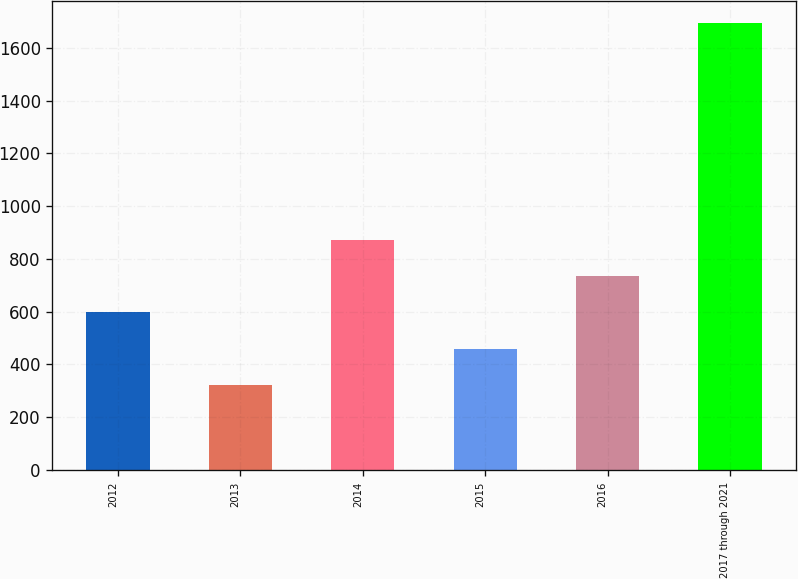Convert chart. <chart><loc_0><loc_0><loc_500><loc_500><bar_chart><fcel>2012<fcel>2013<fcel>2014<fcel>2015<fcel>2016<fcel>2017 through 2021<nl><fcel>597.2<fcel>323<fcel>871.4<fcel>460.1<fcel>734.3<fcel>1694<nl></chart> 